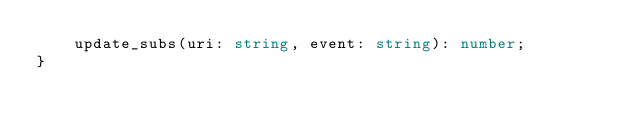<code> <loc_0><loc_0><loc_500><loc_500><_TypeScript_>    update_subs(uri: string, event: string): number;
}
</code> 